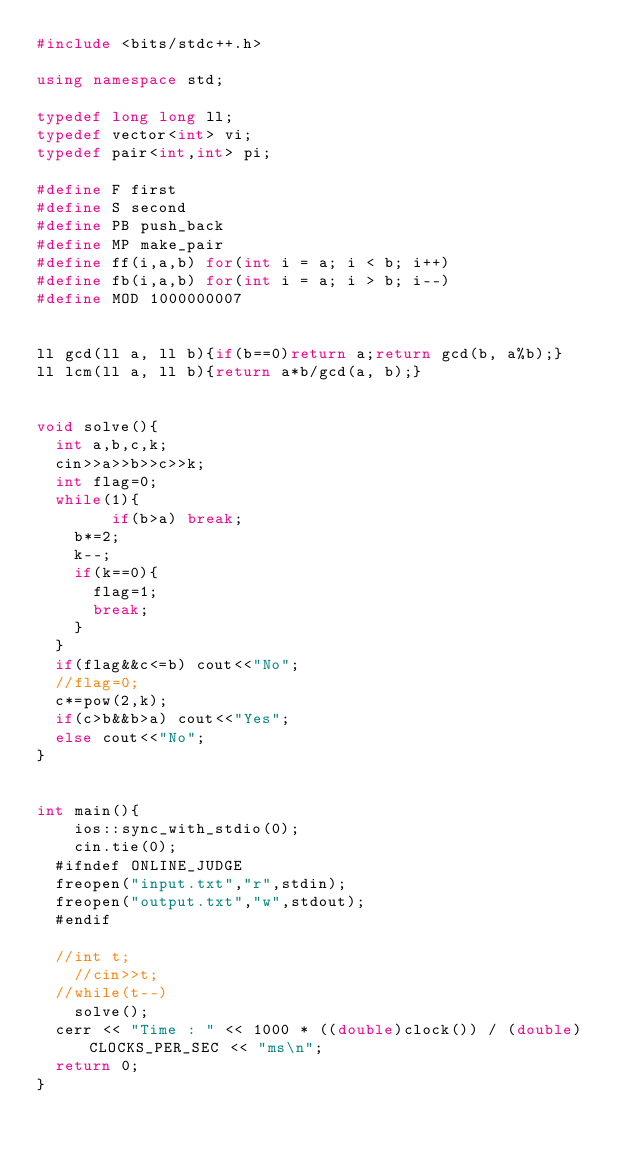Convert code to text. <code><loc_0><loc_0><loc_500><loc_500><_C++_>#include <bits/stdc++.h>

using namespace std;

typedef long long ll;
typedef vector<int> vi;
typedef pair<int,int> pi;

#define F first
#define S second
#define PB push_back
#define MP make_pair
#define ff(i,a,b) for(int i = a; i < b; i++)
#define fb(i,a,b) for(int i = a; i > b; i--)
#define MOD 1000000007


ll gcd(ll a, ll b){if(b==0)return a;return gcd(b, a%b);}
ll lcm(ll a, ll b){return a*b/gcd(a, b);}


void solve(){
	int a,b,c,k;
	cin>>a>>b>>c>>k;
	int flag=0;
	while(1){
        if(b>a) break;
		b*=2;
		k--;
		if(k==0){
			flag=1;
			break;
		}
	}
	if(flag&&c<=b) cout<<"No";
	//flag=0;
	c*=pow(2,k);
	if(c>b&&b>a) cout<<"Yes";
	else cout<<"No";
}


int main(){
    ios::sync_with_stdio(0);
    cin.tie(0);
	#ifndef ONLINE_JUDGE
	freopen("input.txt","r",stdin);
	freopen("output.txt","w",stdout);
	#endif

	//int t;
    //cin>>t;
	//while(t--)
		solve();
	cerr << "Time : " << 1000 * ((double)clock()) / (double)CLOCKS_PER_SEC << "ms\n";
	return 0;
}</code> 